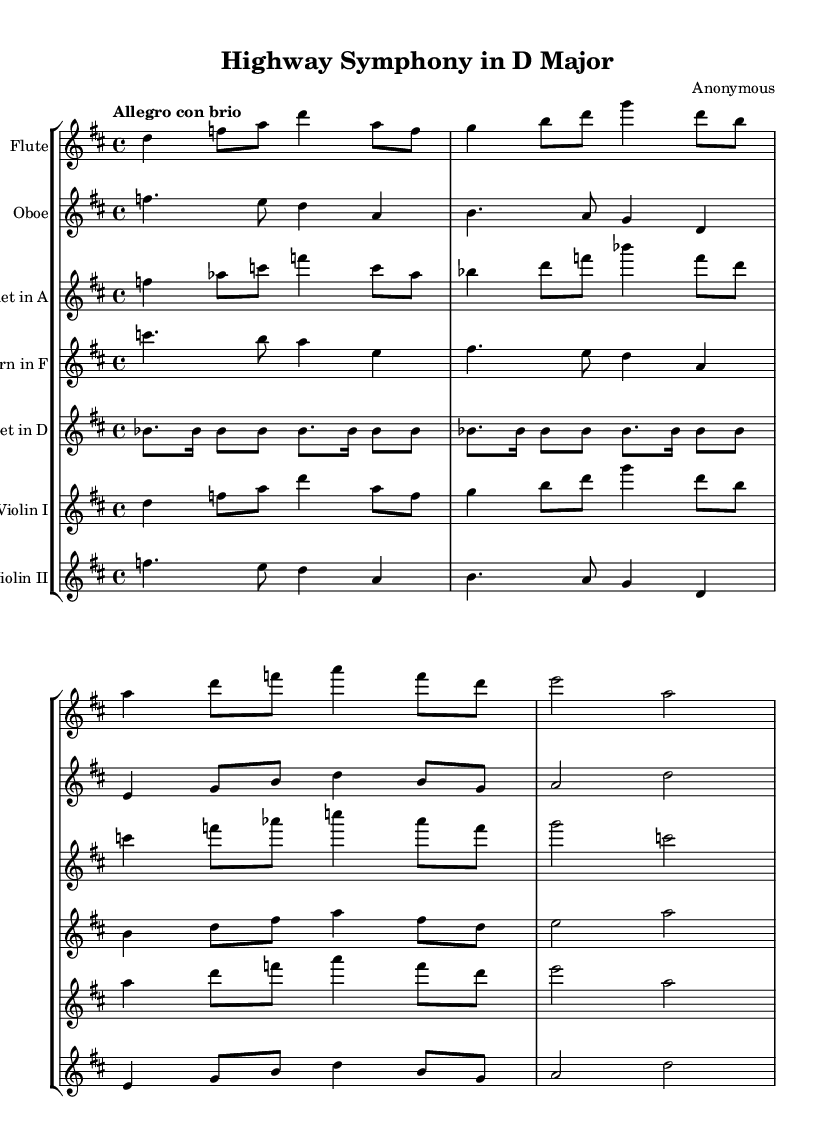What is the key signature of this music? The key signature is indicated at the beginning of the staff, which shows two sharps: F# and C#. This corresponds to D major.
Answer: D major What is the time signature of this music? The time signature is found at the start of the score, displayed as a fraction. It reads 4/4, meaning there are four beats in a measure and the quarter note gets one beat.
Answer: 4/4 What is the tempo marking of this piece? The tempo marking appears above the staff, indicating the speed of the piece. It states "Allegro con brio", which suggests a fast and lively pace.
Answer: Allegro con brio How many different instruments are represented in the score? By counting the distinct staves labeled with different instrument names, we find there are six different instruments present: flute, oboe, clarinet in A, horn in F, trumpet in D, violin I, and violin II.
Answer: Six What does the rhythmic motif consist of? The rhythmic motif is denoted within the staff for the trumpet and consists of repeated eighth and sixteenth notes, which creates a distinctive rhythmic pattern.
Answer: Eighth and sixteenth notes Which theme does the Flute play? Since the Flute staff is labeled and corresponds to the initial theme presented, it can be reasoned that the Flute plays the main theme.
Answer: Main theme What is unique about the Clarinet's part in relation to concert pitch? The Clarinet is indicated to be in A, which means it plays one whole step higher than written for concert pitch, requiring a transposition that must be acknowledged when reading the part compared to sounding pitch.
Answer: Transposed part 